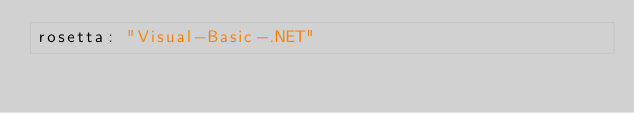Convert code to text. <code><loc_0><loc_0><loc_500><loc_500><_YAML_>rosetta: "Visual-Basic-.NET"
</code> 